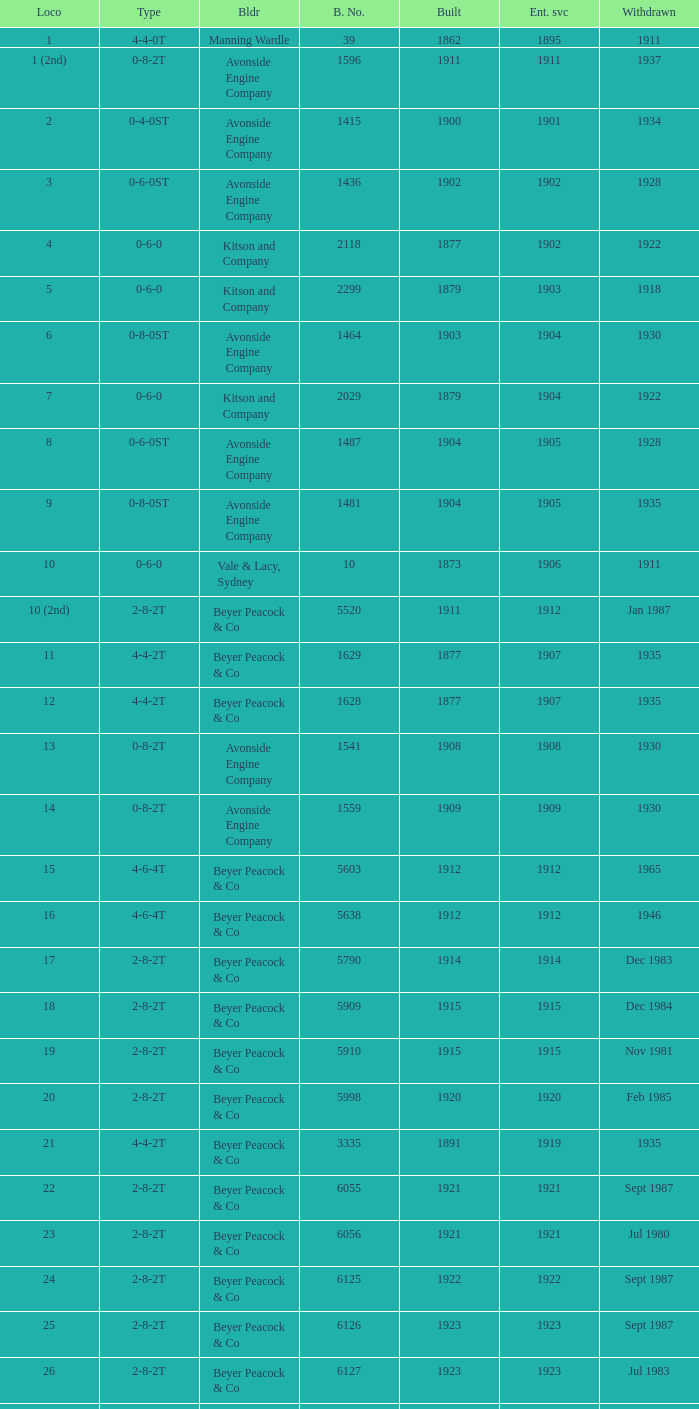How many years entered service when there were 13 locomotives? 1.0. 